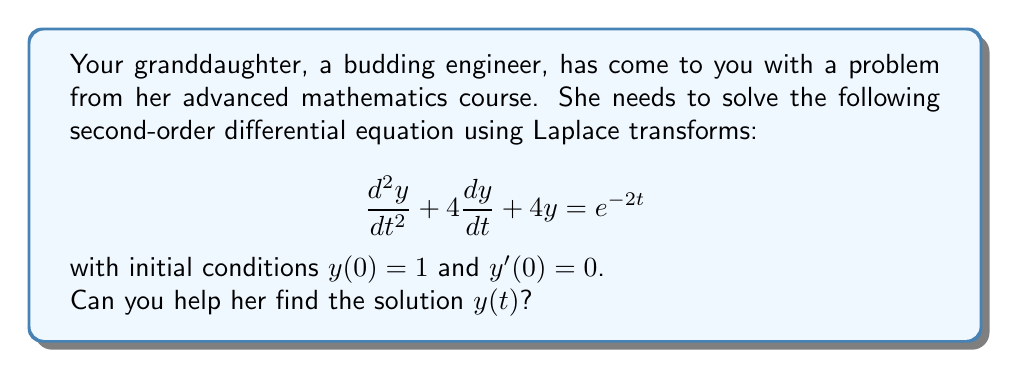Teach me how to tackle this problem. Let's approach this step-by-step using Laplace transforms:

1) First, we take the Laplace transform of both sides of the equation. Let $Y(s) = \mathcal{L}\{y(t)\}$.

   $\mathcal{L}\{\frac{d^2y}{dt^2} + 4\frac{dy}{dt} + 4y\} = \mathcal{L}\{e^{-2t}\}$

2) Using Laplace transform properties:

   $[s^2Y(s) - sy(0) - y'(0)] + 4[sY(s) - y(0)] + 4Y(s) = \frac{1}{s+2}$

3) Substitute the initial conditions $y(0) = 1$ and $y'(0) = 0$:

   $[s^2Y(s) - s - 0] + 4[sY(s) - 1] + 4Y(s) = \frac{1}{s+2}$

4) Simplify:

   $s^2Y(s) + 4sY(s) + 4Y(s) - s - 4 = \frac{1}{s+2}$

   $(s^2 + 4s + 4)Y(s) = \frac{1}{s+2} + s + 4$

5) Factor the left side:

   $(s+2)^2Y(s) = \frac{1}{s+2} + s + 4$

6) Solve for $Y(s)$:

   $Y(s) = \frac{1}{(s+2)^3} + \frac{s}{(s+2)^2} + \frac{4}{(s+2)^2}$

7) Now we need to find the inverse Laplace transform. We can use partial fraction decomposition:

   $Y(s) = \frac{1}{(s+2)^3} + \frac{s+4}{(s+2)^2}$

8) Taking the inverse Laplace transform:

   $y(t) = \mathcal{L}^{-1}\{\frac{1}{(s+2)^3}\} + \mathcal{L}^{-1}\{\frac{s+4}{(s+2)^2}\}$

9) Using Laplace transform tables:

   $y(t) = \frac{1}{2}t^2e^{-2t} + (1+2t)e^{-2t}$

10) Simplify:

    $y(t) = (\frac{1}{2}t^2 + 2t + 1)e^{-2t}$

This is the solution to the differential equation.
Answer: $y(t) = (\frac{1}{2}t^2 + 2t + 1)e^{-2t}$ 